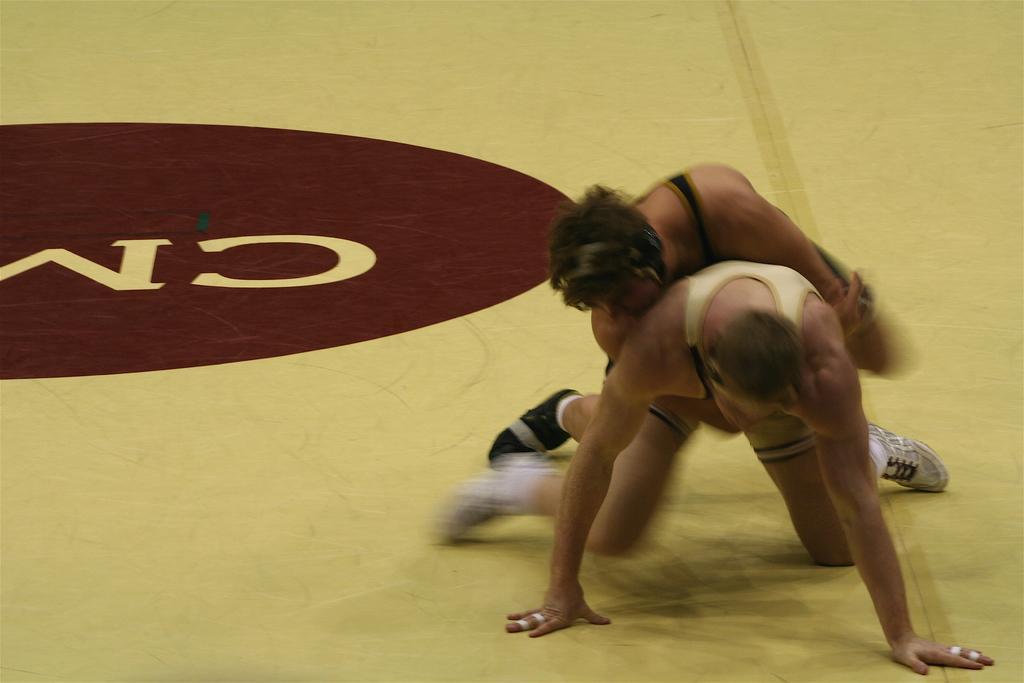How would you summarize this image in a sentence or two? In this picture we can see two persons on the ground where a person is holding another person. 